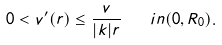<formula> <loc_0><loc_0><loc_500><loc_500>0 < v ^ { \prime } ( r ) \leq \frac { v } { | k | r } \quad i n ( 0 , R _ { 0 } ) .</formula> 